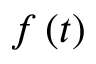Convert formula to latex. <formula><loc_0><loc_0><loc_500><loc_500>f \left ( t \right )</formula> 